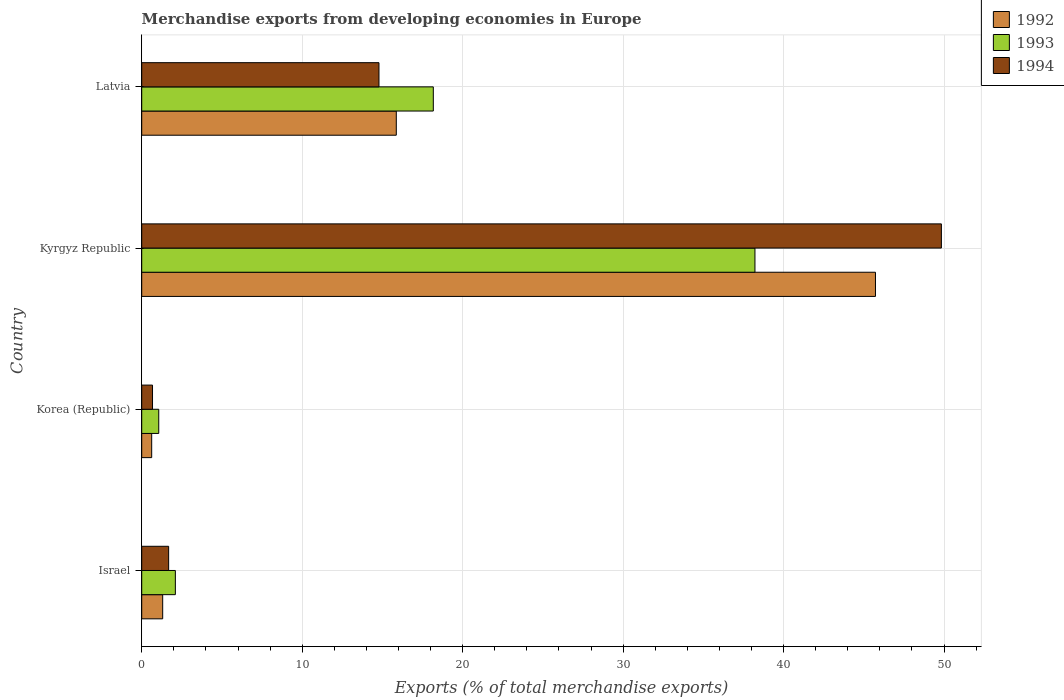How many different coloured bars are there?
Keep it short and to the point. 3. Are the number of bars on each tick of the Y-axis equal?
Your answer should be compact. Yes. How many bars are there on the 1st tick from the top?
Give a very brief answer. 3. How many bars are there on the 1st tick from the bottom?
Offer a terse response. 3. What is the label of the 1st group of bars from the top?
Your response must be concise. Latvia. What is the percentage of total merchandise exports in 1994 in Korea (Republic)?
Your answer should be compact. 0.67. Across all countries, what is the maximum percentage of total merchandise exports in 1992?
Provide a succinct answer. 45.73. Across all countries, what is the minimum percentage of total merchandise exports in 1992?
Your response must be concise. 0.62. In which country was the percentage of total merchandise exports in 1993 maximum?
Offer a very short reply. Kyrgyz Republic. What is the total percentage of total merchandise exports in 1994 in the graph?
Ensure brevity in your answer.  66.97. What is the difference between the percentage of total merchandise exports in 1994 in Korea (Republic) and that in Kyrgyz Republic?
Provide a short and direct response. -49.16. What is the difference between the percentage of total merchandise exports in 1994 in Kyrgyz Republic and the percentage of total merchandise exports in 1993 in Latvia?
Offer a very short reply. 31.66. What is the average percentage of total merchandise exports in 1993 per country?
Keep it short and to the point. 14.89. What is the difference between the percentage of total merchandise exports in 1992 and percentage of total merchandise exports in 1993 in Kyrgyz Republic?
Offer a terse response. 7.51. In how many countries, is the percentage of total merchandise exports in 1992 greater than 44 %?
Your answer should be very brief. 1. What is the ratio of the percentage of total merchandise exports in 1993 in Korea (Republic) to that in Latvia?
Provide a succinct answer. 0.06. Is the percentage of total merchandise exports in 1992 in Israel less than that in Korea (Republic)?
Your answer should be compact. No. Is the difference between the percentage of total merchandise exports in 1992 in Korea (Republic) and Kyrgyz Republic greater than the difference between the percentage of total merchandise exports in 1993 in Korea (Republic) and Kyrgyz Republic?
Provide a succinct answer. No. What is the difference between the highest and the second highest percentage of total merchandise exports in 1994?
Ensure brevity in your answer.  35.05. What is the difference between the highest and the lowest percentage of total merchandise exports in 1993?
Your answer should be compact. 37.16. Is the sum of the percentage of total merchandise exports in 1994 in Israel and Korea (Republic) greater than the maximum percentage of total merchandise exports in 1992 across all countries?
Keep it short and to the point. No. How many bars are there?
Your answer should be compact. 12. What is the difference between two consecutive major ticks on the X-axis?
Your response must be concise. 10. Does the graph contain grids?
Give a very brief answer. Yes. Where does the legend appear in the graph?
Your response must be concise. Top right. How many legend labels are there?
Your answer should be very brief. 3. What is the title of the graph?
Make the answer very short. Merchandise exports from developing economies in Europe. What is the label or title of the X-axis?
Offer a terse response. Exports (% of total merchandise exports). What is the Exports (% of total merchandise exports) of 1992 in Israel?
Offer a terse response. 1.31. What is the Exports (% of total merchandise exports) in 1993 in Israel?
Provide a short and direct response. 2.1. What is the Exports (% of total merchandise exports) of 1994 in Israel?
Give a very brief answer. 1.68. What is the Exports (% of total merchandise exports) of 1992 in Korea (Republic)?
Provide a short and direct response. 0.62. What is the Exports (% of total merchandise exports) in 1993 in Korea (Republic)?
Make the answer very short. 1.06. What is the Exports (% of total merchandise exports) in 1994 in Korea (Republic)?
Provide a short and direct response. 0.67. What is the Exports (% of total merchandise exports) in 1992 in Kyrgyz Republic?
Provide a short and direct response. 45.73. What is the Exports (% of total merchandise exports) in 1993 in Kyrgyz Republic?
Make the answer very short. 38.22. What is the Exports (% of total merchandise exports) in 1994 in Kyrgyz Republic?
Your answer should be very brief. 49.84. What is the Exports (% of total merchandise exports) in 1992 in Latvia?
Make the answer very short. 15.87. What is the Exports (% of total merchandise exports) of 1993 in Latvia?
Ensure brevity in your answer.  18.17. What is the Exports (% of total merchandise exports) of 1994 in Latvia?
Provide a succinct answer. 14.79. Across all countries, what is the maximum Exports (% of total merchandise exports) of 1992?
Make the answer very short. 45.73. Across all countries, what is the maximum Exports (% of total merchandise exports) of 1993?
Your response must be concise. 38.22. Across all countries, what is the maximum Exports (% of total merchandise exports) in 1994?
Make the answer very short. 49.84. Across all countries, what is the minimum Exports (% of total merchandise exports) in 1992?
Give a very brief answer. 0.62. Across all countries, what is the minimum Exports (% of total merchandise exports) of 1993?
Make the answer very short. 1.06. Across all countries, what is the minimum Exports (% of total merchandise exports) in 1994?
Make the answer very short. 0.67. What is the total Exports (% of total merchandise exports) in 1992 in the graph?
Offer a very short reply. 63.52. What is the total Exports (% of total merchandise exports) in 1993 in the graph?
Your response must be concise. 59.55. What is the total Exports (% of total merchandise exports) of 1994 in the graph?
Provide a short and direct response. 66.97. What is the difference between the Exports (% of total merchandise exports) of 1992 in Israel and that in Korea (Republic)?
Your answer should be very brief. 0.69. What is the difference between the Exports (% of total merchandise exports) in 1993 in Israel and that in Korea (Republic)?
Offer a terse response. 1.03. What is the difference between the Exports (% of total merchandise exports) of 1994 in Israel and that in Korea (Republic)?
Make the answer very short. 1.01. What is the difference between the Exports (% of total merchandise exports) in 1992 in Israel and that in Kyrgyz Republic?
Your response must be concise. -44.42. What is the difference between the Exports (% of total merchandise exports) in 1993 in Israel and that in Kyrgyz Republic?
Your answer should be compact. -36.12. What is the difference between the Exports (% of total merchandise exports) of 1994 in Israel and that in Kyrgyz Republic?
Offer a very short reply. -48.16. What is the difference between the Exports (% of total merchandise exports) of 1992 in Israel and that in Latvia?
Keep it short and to the point. -14.56. What is the difference between the Exports (% of total merchandise exports) of 1993 in Israel and that in Latvia?
Your answer should be very brief. -16.08. What is the difference between the Exports (% of total merchandise exports) of 1994 in Israel and that in Latvia?
Give a very brief answer. -13.11. What is the difference between the Exports (% of total merchandise exports) in 1992 in Korea (Republic) and that in Kyrgyz Republic?
Give a very brief answer. -45.11. What is the difference between the Exports (% of total merchandise exports) of 1993 in Korea (Republic) and that in Kyrgyz Republic?
Provide a succinct answer. -37.16. What is the difference between the Exports (% of total merchandise exports) in 1994 in Korea (Republic) and that in Kyrgyz Republic?
Your answer should be very brief. -49.16. What is the difference between the Exports (% of total merchandise exports) in 1992 in Korea (Republic) and that in Latvia?
Provide a short and direct response. -15.25. What is the difference between the Exports (% of total merchandise exports) of 1993 in Korea (Republic) and that in Latvia?
Provide a succinct answer. -17.11. What is the difference between the Exports (% of total merchandise exports) of 1994 in Korea (Republic) and that in Latvia?
Your response must be concise. -14.11. What is the difference between the Exports (% of total merchandise exports) in 1992 in Kyrgyz Republic and that in Latvia?
Ensure brevity in your answer.  29.86. What is the difference between the Exports (% of total merchandise exports) of 1993 in Kyrgyz Republic and that in Latvia?
Give a very brief answer. 20.04. What is the difference between the Exports (% of total merchandise exports) in 1994 in Kyrgyz Republic and that in Latvia?
Offer a terse response. 35.05. What is the difference between the Exports (% of total merchandise exports) of 1992 in Israel and the Exports (% of total merchandise exports) of 1993 in Korea (Republic)?
Provide a succinct answer. 0.25. What is the difference between the Exports (% of total merchandise exports) of 1992 in Israel and the Exports (% of total merchandise exports) of 1994 in Korea (Republic)?
Your answer should be very brief. 0.63. What is the difference between the Exports (% of total merchandise exports) of 1993 in Israel and the Exports (% of total merchandise exports) of 1994 in Korea (Republic)?
Keep it short and to the point. 1.42. What is the difference between the Exports (% of total merchandise exports) of 1992 in Israel and the Exports (% of total merchandise exports) of 1993 in Kyrgyz Republic?
Give a very brief answer. -36.91. What is the difference between the Exports (% of total merchandise exports) of 1992 in Israel and the Exports (% of total merchandise exports) of 1994 in Kyrgyz Republic?
Make the answer very short. -48.53. What is the difference between the Exports (% of total merchandise exports) of 1993 in Israel and the Exports (% of total merchandise exports) of 1994 in Kyrgyz Republic?
Provide a short and direct response. -47.74. What is the difference between the Exports (% of total merchandise exports) of 1992 in Israel and the Exports (% of total merchandise exports) of 1993 in Latvia?
Your answer should be compact. -16.87. What is the difference between the Exports (% of total merchandise exports) in 1992 in Israel and the Exports (% of total merchandise exports) in 1994 in Latvia?
Give a very brief answer. -13.48. What is the difference between the Exports (% of total merchandise exports) of 1993 in Israel and the Exports (% of total merchandise exports) of 1994 in Latvia?
Your answer should be very brief. -12.69. What is the difference between the Exports (% of total merchandise exports) of 1992 in Korea (Republic) and the Exports (% of total merchandise exports) of 1993 in Kyrgyz Republic?
Make the answer very short. -37.6. What is the difference between the Exports (% of total merchandise exports) of 1992 in Korea (Republic) and the Exports (% of total merchandise exports) of 1994 in Kyrgyz Republic?
Offer a terse response. -49.22. What is the difference between the Exports (% of total merchandise exports) in 1993 in Korea (Republic) and the Exports (% of total merchandise exports) in 1994 in Kyrgyz Republic?
Give a very brief answer. -48.77. What is the difference between the Exports (% of total merchandise exports) of 1992 in Korea (Republic) and the Exports (% of total merchandise exports) of 1993 in Latvia?
Your response must be concise. -17.55. What is the difference between the Exports (% of total merchandise exports) of 1992 in Korea (Republic) and the Exports (% of total merchandise exports) of 1994 in Latvia?
Offer a very short reply. -14.16. What is the difference between the Exports (% of total merchandise exports) of 1993 in Korea (Republic) and the Exports (% of total merchandise exports) of 1994 in Latvia?
Ensure brevity in your answer.  -13.72. What is the difference between the Exports (% of total merchandise exports) in 1992 in Kyrgyz Republic and the Exports (% of total merchandise exports) in 1993 in Latvia?
Your response must be concise. 27.56. What is the difference between the Exports (% of total merchandise exports) of 1992 in Kyrgyz Republic and the Exports (% of total merchandise exports) of 1994 in Latvia?
Offer a very short reply. 30.94. What is the difference between the Exports (% of total merchandise exports) of 1993 in Kyrgyz Republic and the Exports (% of total merchandise exports) of 1994 in Latvia?
Provide a short and direct response. 23.43. What is the average Exports (% of total merchandise exports) in 1992 per country?
Your response must be concise. 15.88. What is the average Exports (% of total merchandise exports) of 1993 per country?
Offer a very short reply. 14.89. What is the average Exports (% of total merchandise exports) of 1994 per country?
Your answer should be compact. 16.74. What is the difference between the Exports (% of total merchandise exports) of 1992 and Exports (% of total merchandise exports) of 1993 in Israel?
Your response must be concise. -0.79. What is the difference between the Exports (% of total merchandise exports) in 1992 and Exports (% of total merchandise exports) in 1994 in Israel?
Keep it short and to the point. -0.37. What is the difference between the Exports (% of total merchandise exports) of 1993 and Exports (% of total merchandise exports) of 1994 in Israel?
Give a very brief answer. 0.42. What is the difference between the Exports (% of total merchandise exports) of 1992 and Exports (% of total merchandise exports) of 1993 in Korea (Republic)?
Offer a very short reply. -0.44. What is the difference between the Exports (% of total merchandise exports) of 1992 and Exports (% of total merchandise exports) of 1994 in Korea (Republic)?
Make the answer very short. -0.05. What is the difference between the Exports (% of total merchandise exports) of 1993 and Exports (% of total merchandise exports) of 1994 in Korea (Republic)?
Your response must be concise. 0.39. What is the difference between the Exports (% of total merchandise exports) in 1992 and Exports (% of total merchandise exports) in 1993 in Kyrgyz Republic?
Give a very brief answer. 7.51. What is the difference between the Exports (% of total merchandise exports) in 1992 and Exports (% of total merchandise exports) in 1994 in Kyrgyz Republic?
Provide a succinct answer. -4.11. What is the difference between the Exports (% of total merchandise exports) of 1993 and Exports (% of total merchandise exports) of 1994 in Kyrgyz Republic?
Provide a short and direct response. -11.62. What is the difference between the Exports (% of total merchandise exports) in 1992 and Exports (% of total merchandise exports) in 1993 in Latvia?
Your answer should be compact. -2.31. What is the difference between the Exports (% of total merchandise exports) in 1992 and Exports (% of total merchandise exports) in 1994 in Latvia?
Your answer should be very brief. 1.08. What is the difference between the Exports (% of total merchandise exports) of 1993 and Exports (% of total merchandise exports) of 1994 in Latvia?
Make the answer very short. 3.39. What is the ratio of the Exports (% of total merchandise exports) of 1992 in Israel to that in Korea (Republic)?
Your answer should be very brief. 2.11. What is the ratio of the Exports (% of total merchandise exports) in 1993 in Israel to that in Korea (Republic)?
Keep it short and to the point. 1.97. What is the ratio of the Exports (% of total merchandise exports) of 1994 in Israel to that in Korea (Republic)?
Offer a terse response. 2.49. What is the ratio of the Exports (% of total merchandise exports) in 1992 in Israel to that in Kyrgyz Republic?
Offer a very short reply. 0.03. What is the ratio of the Exports (% of total merchandise exports) in 1993 in Israel to that in Kyrgyz Republic?
Offer a very short reply. 0.05. What is the ratio of the Exports (% of total merchandise exports) of 1994 in Israel to that in Kyrgyz Republic?
Your answer should be very brief. 0.03. What is the ratio of the Exports (% of total merchandise exports) in 1992 in Israel to that in Latvia?
Your answer should be compact. 0.08. What is the ratio of the Exports (% of total merchandise exports) of 1993 in Israel to that in Latvia?
Ensure brevity in your answer.  0.12. What is the ratio of the Exports (% of total merchandise exports) of 1994 in Israel to that in Latvia?
Make the answer very short. 0.11. What is the ratio of the Exports (% of total merchandise exports) in 1992 in Korea (Republic) to that in Kyrgyz Republic?
Offer a very short reply. 0.01. What is the ratio of the Exports (% of total merchandise exports) in 1993 in Korea (Republic) to that in Kyrgyz Republic?
Your answer should be compact. 0.03. What is the ratio of the Exports (% of total merchandise exports) of 1994 in Korea (Republic) to that in Kyrgyz Republic?
Provide a succinct answer. 0.01. What is the ratio of the Exports (% of total merchandise exports) of 1992 in Korea (Republic) to that in Latvia?
Ensure brevity in your answer.  0.04. What is the ratio of the Exports (% of total merchandise exports) in 1993 in Korea (Republic) to that in Latvia?
Your response must be concise. 0.06. What is the ratio of the Exports (% of total merchandise exports) of 1994 in Korea (Republic) to that in Latvia?
Offer a very short reply. 0.05. What is the ratio of the Exports (% of total merchandise exports) of 1992 in Kyrgyz Republic to that in Latvia?
Your response must be concise. 2.88. What is the ratio of the Exports (% of total merchandise exports) of 1993 in Kyrgyz Republic to that in Latvia?
Give a very brief answer. 2.1. What is the ratio of the Exports (% of total merchandise exports) in 1994 in Kyrgyz Republic to that in Latvia?
Keep it short and to the point. 3.37. What is the difference between the highest and the second highest Exports (% of total merchandise exports) in 1992?
Provide a succinct answer. 29.86. What is the difference between the highest and the second highest Exports (% of total merchandise exports) of 1993?
Offer a very short reply. 20.04. What is the difference between the highest and the second highest Exports (% of total merchandise exports) in 1994?
Provide a succinct answer. 35.05. What is the difference between the highest and the lowest Exports (% of total merchandise exports) in 1992?
Provide a short and direct response. 45.11. What is the difference between the highest and the lowest Exports (% of total merchandise exports) of 1993?
Provide a short and direct response. 37.16. What is the difference between the highest and the lowest Exports (% of total merchandise exports) in 1994?
Offer a very short reply. 49.16. 